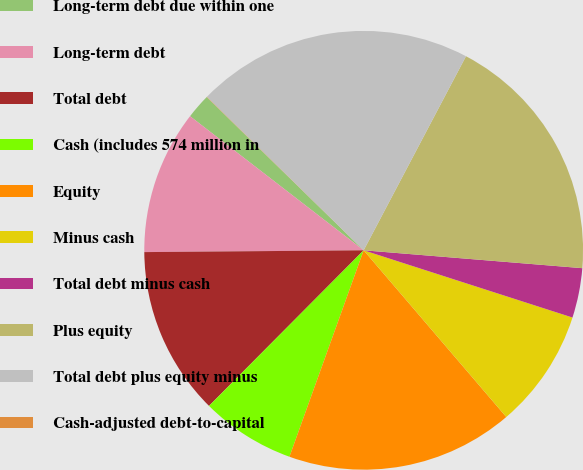Convert chart. <chart><loc_0><loc_0><loc_500><loc_500><pie_chart><fcel>Long-term debt due within one<fcel>Long-term debt<fcel>Total debt<fcel>Cash (includes 574 million in<fcel>Equity<fcel>Minus cash<fcel>Total debt minus cash<fcel>Plus equity<fcel>Total debt plus equity minus<fcel>Cash-adjusted debt-to-capital<nl><fcel>1.84%<fcel>10.6%<fcel>12.42%<fcel>6.96%<fcel>16.76%<fcel>8.78%<fcel>3.66%<fcel>18.58%<fcel>20.4%<fcel>0.02%<nl></chart> 